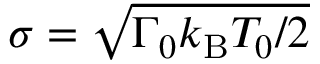<formula> <loc_0><loc_0><loc_500><loc_500>\sigma = \sqrt { { \Gamma _ { 0 } k _ { B } T _ { 0 } } / { 2 } }</formula> 